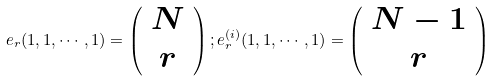<formula> <loc_0><loc_0><loc_500><loc_500>e _ { r } ( 1 , 1 , \cdots , 1 ) = \left ( \begin{array} { c } N \\ r \end{array} \right ) ; e _ { r } ^ { ( i ) } ( 1 , 1 , \cdots , 1 ) = \left ( \begin{array} { c } N - 1 \\ r \end{array} \right )</formula> 